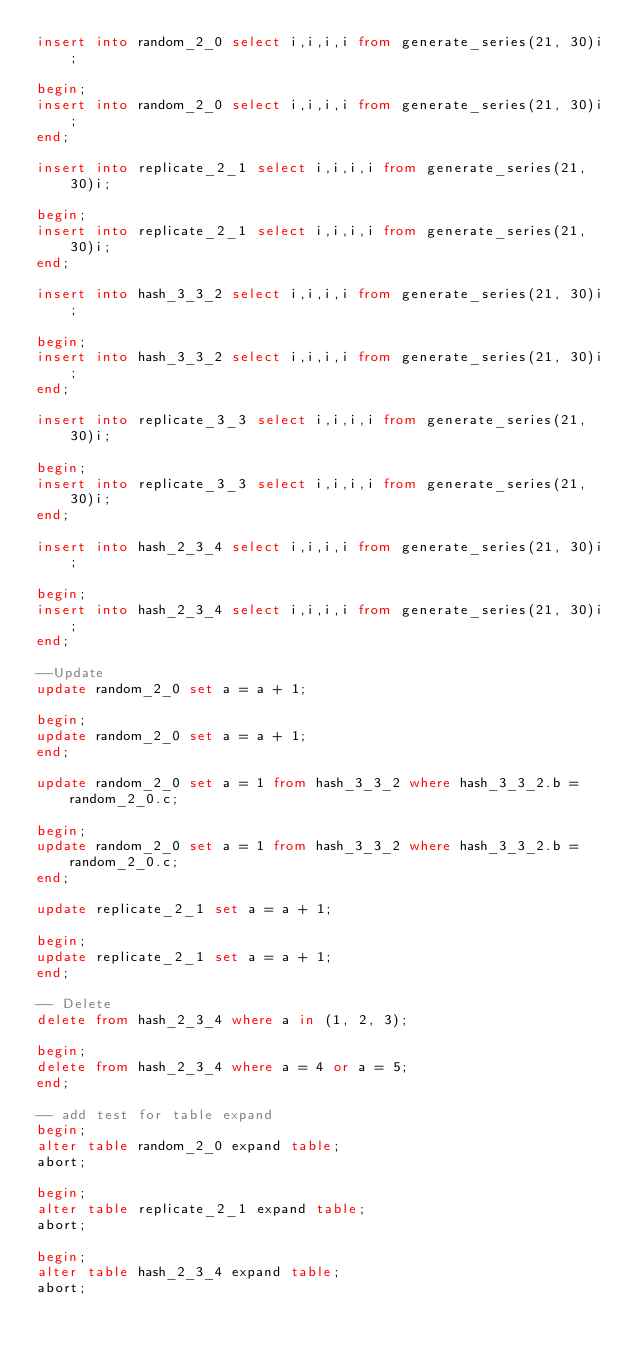<code> <loc_0><loc_0><loc_500><loc_500><_SQL_>insert into random_2_0 select i,i,i,i from generate_series(21, 30)i;

begin;
insert into random_2_0 select i,i,i,i from generate_series(21, 30)i;
end;

insert into replicate_2_1 select i,i,i,i from generate_series(21, 30)i;

begin;
insert into replicate_2_1 select i,i,i,i from generate_series(21, 30)i;
end;

insert into hash_3_3_2 select i,i,i,i from generate_series(21, 30)i;

begin;
insert into hash_3_3_2 select i,i,i,i from generate_series(21, 30)i;
end;

insert into replicate_3_3 select i,i,i,i from generate_series(21, 30)i;

begin;
insert into replicate_3_3 select i,i,i,i from generate_series(21, 30)i;
end;

insert into hash_2_3_4 select i,i,i,i from generate_series(21, 30)i;

begin;
insert into hash_2_3_4 select i,i,i,i from generate_series(21, 30)i;
end;

--Update
update random_2_0 set a = a + 1;

begin;
update random_2_0 set a = a + 1;
end;

update random_2_0 set a = 1 from hash_3_3_2 where hash_3_3_2.b = random_2_0.c;

begin;
update random_2_0 set a = 1 from hash_3_3_2 where hash_3_3_2.b = random_2_0.c;
end;

update replicate_2_1 set a = a + 1;

begin;
update replicate_2_1 set a = a + 1;
end;

-- Delete
delete from hash_2_3_4 where a in (1, 2, 3);

begin;
delete from hash_2_3_4 where a = 4 or a = 5;
end;

-- add test for table expand
begin;
alter table random_2_0 expand table;
abort;

begin;
alter table replicate_2_1 expand table;
abort;

begin;
alter table hash_2_3_4 expand table;
abort;
</code> 